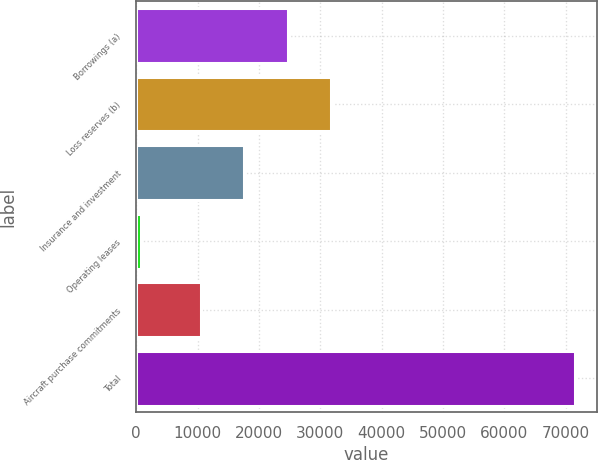Convert chart to OTSL. <chart><loc_0><loc_0><loc_500><loc_500><bar_chart><fcel>Borrowings (a)<fcel>Loss reserves (b)<fcel>Insurance and investment<fcel>Operating leases<fcel>Aircraft purchase commitments<fcel>Total<nl><fcel>24683.4<fcel>31763.1<fcel>17603.7<fcel>761<fcel>10524<fcel>71558<nl></chart> 